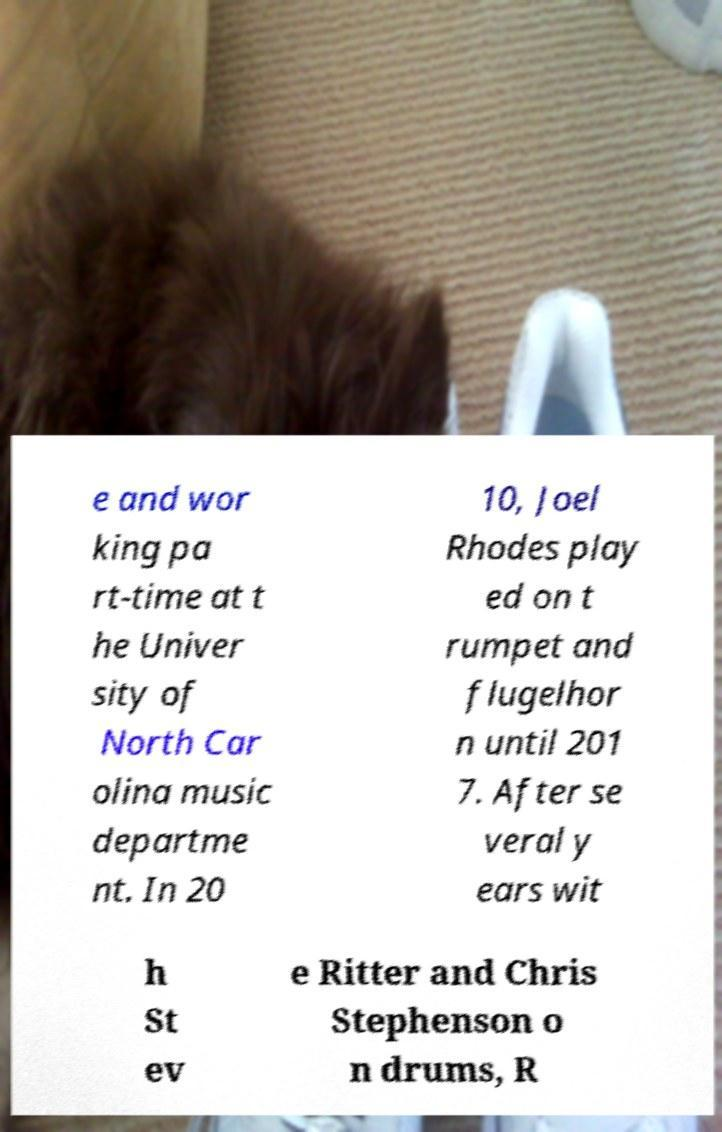Can you read and provide the text displayed in the image?This photo seems to have some interesting text. Can you extract and type it out for me? e and wor king pa rt-time at t he Univer sity of North Car olina music departme nt. In 20 10, Joel Rhodes play ed on t rumpet and flugelhor n until 201 7. After se veral y ears wit h St ev e Ritter and Chris Stephenson o n drums, R 